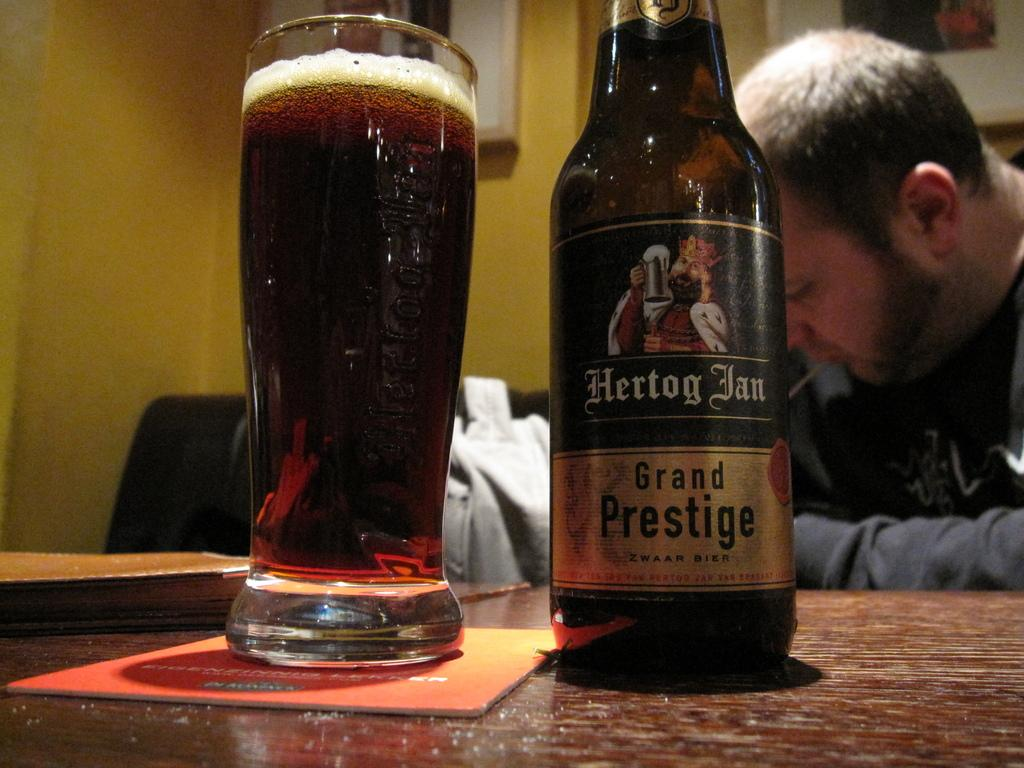<image>
Present a compact description of the photo's key features. a bottle of Hertog Ian Grand Prestige by a glass 